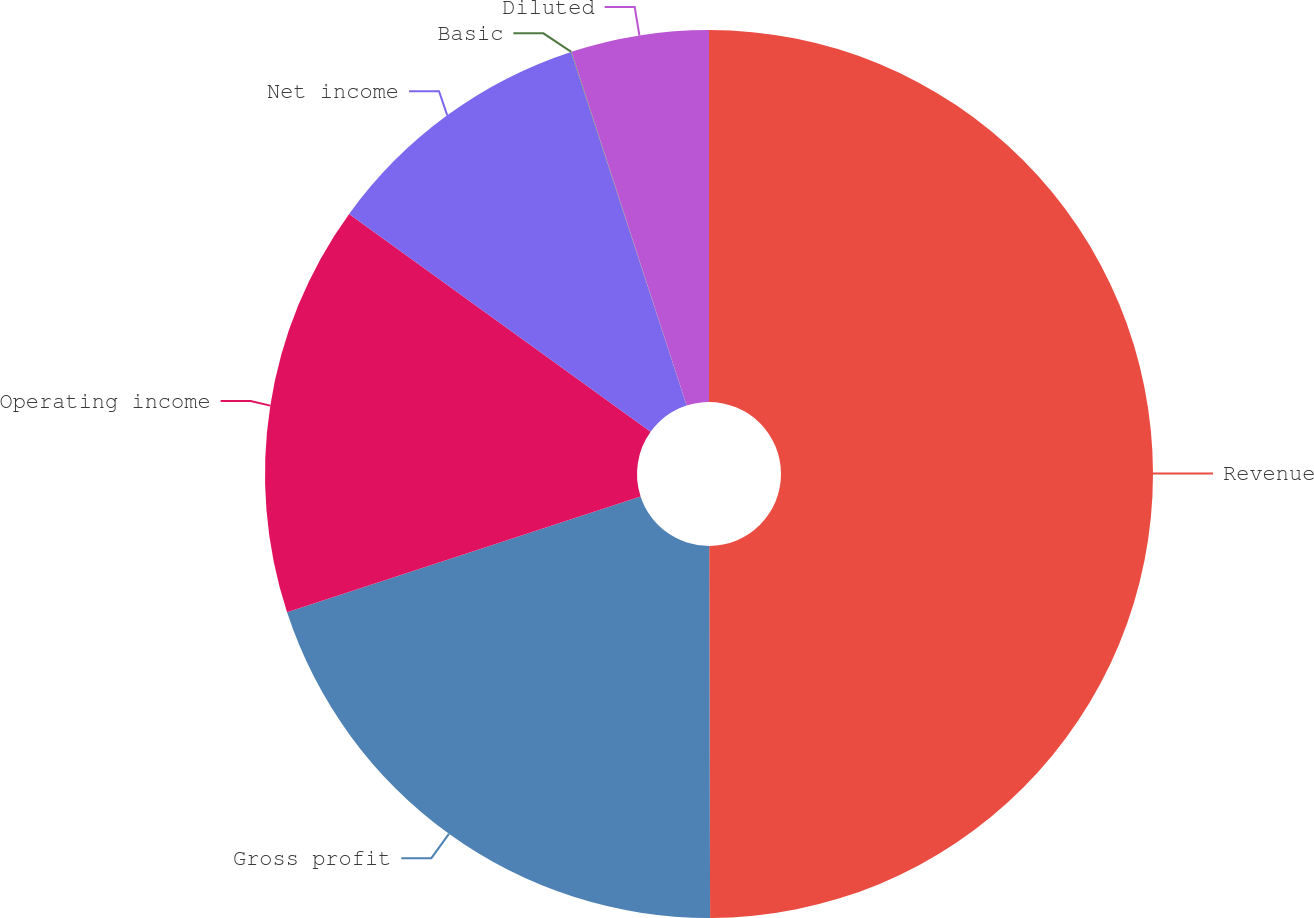<chart> <loc_0><loc_0><loc_500><loc_500><pie_chart><fcel>Revenue<fcel>Gross profit<fcel>Operating income<fcel>Net income<fcel>Basic<fcel>Diluted<nl><fcel>49.96%<fcel>20.0%<fcel>15.0%<fcel>10.01%<fcel>0.02%<fcel>5.01%<nl></chart> 